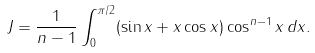Convert formula to latex. <formula><loc_0><loc_0><loc_500><loc_500>J = \frac { 1 } { n - 1 } \int _ { 0 } ^ { \pi / 2 } ( \sin x + x \cos x ) \cos ^ { n - 1 } x \, d x .</formula> 